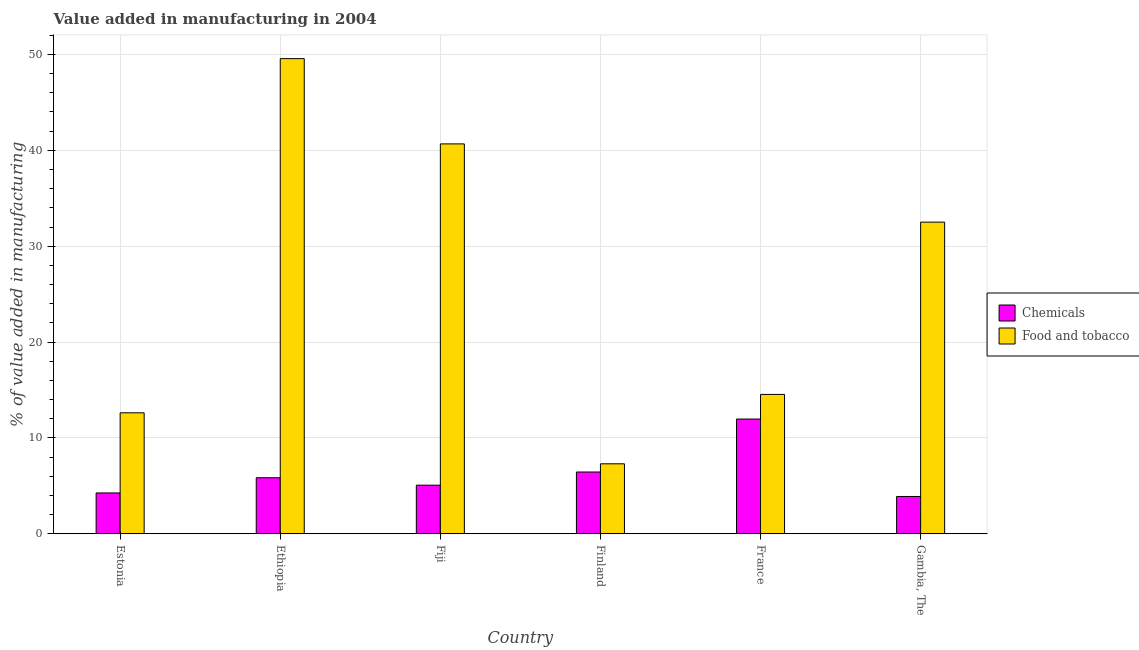How many different coloured bars are there?
Offer a terse response. 2. Are the number of bars per tick equal to the number of legend labels?
Give a very brief answer. Yes. How many bars are there on the 6th tick from the right?
Offer a terse response. 2. What is the label of the 4th group of bars from the left?
Your answer should be very brief. Finland. What is the value added by  manufacturing chemicals in Estonia?
Offer a very short reply. 4.27. Across all countries, what is the maximum value added by  manufacturing chemicals?
Ensure brevity in your answer.  11.97. Across all countries, what is the minimum value added by  manufacturing chemicals?
Provide a succinct answer. 3.9. In which country was the value added by manufacturing food and tobacco maximum?
Offer a terse response. Ethiopia. In which country was the value added by  manufacturing chemicals minimum?
Offer a terse response. Gambia, The. What is the total value added by  manufacturing chemicals in the graph?
Offer a terse response. 37.52. What is the difference between the value added by  manufacturing chemicals in Ethiopia and that in France?
Offer a terse response. -6.12. What is the difference between the value added by  manufacturing chemicals in Gambia, The and the value added by manufacturing food and tobacco in France?
Ensure brevity in your answer.  -10.64. What is the average value added by manufacturing food and tobacco per country?
Provide a succinct answer. 26.2. What is the difference between the value added by  manufacturing chemicals and value added by manufacturing food and tobacco in Finland?
Your answer should be compact. -0.86. In how many countries, is the value added by  manufacturing chemicals greater than 48 %?
Your response must be concise. 0. What is the ratio of the value added by manufacturing food and tobacco in Ethiopia to that in Finland?
Your answer should be very brief. 6.78. Is the value added by  manufacturing chemicals in Ethiopia less than that in France?
Offer a terse response. Yes. Is the difference between the value added by manufacturing food and tobacco in Estonia and Finland greater than the difference between the value added by  manufacturing chemicals in Estonia and Finland?
Provide a short and direct response. Yes. What is the difference between the highest and the second highest value added by  manufacturing chemicals?
Provide a short and direct response. 5.52. What is the difference between the highest and the lowest value added by  manufacturing chemicals?
Your response must be concise. 8.08. What does the 1st bar from the left in Finland represents?
Make the answer very short. Chemicals. What does the 1st bar from the right in Fiji represents?
Offer a terse response. Food and tobacco. How many countries are there in the graph?
Your response must be concise. 6. What is the difference between two consecutive major ticks on the Y-axis?
Keep it short and to the point. 10. Are the values on the major ticks of Y-axis written in scientific E-notation?
Make the answer very short. No. Does the graph contain any zero values?
Offer a very short reply. No. Does the graph contain grids?
Give a very brief answer. Yes. Where does the legend appear in the graph?
Give a very brief answer. Center right. How many legend labels are there?
Your answer should be compact. 2. How are the legend labels stacked?
Provide a succinct answer. Vertical. What is the title of the graph?
Keep it short and to the point. Value added in manufacturing in 2004. What is the label or title of the X-axis?
Give a very brief answer. Country. What is the label or title of the Y-axis?
Your response must be concise. % of value added in manufacturing. What is the % of value added in manufacturing of Chemicals in Estonia?
Your answer should be very brief. 4.27. What is the % of value added in manufacturing of Food and tobacco in Estonia?
Give a very brief answer. 12.63. What is the % of value added in manufacturing in Chemicals in Ethiopia?
Ensure brevity in your answer.  5.85. What is the % of value added in manufacturing in Food and tobacco in Ethiopia?
Give a very brief answer. 49.56. What is the % of value added in manufacturing of Chemicals in Fiji?
Offer a very short reply. 5.08. What is the % of value added in manufacturing in Food and tobacco in Fiji?
Provide a succinct answer. 40.67. What is the % of value added in manufacturing in Chemicals in Finland?
Your response must be concise. 6.45. What is the % of value added in manufacturing in Food and tobacco in Finland?
Provide a short and direct response. 7.31. What is the % of value added in manufacturing in Chemicals in France?
Make the answer very short. 11.97. What is the % of value added in manufacturing of Food and tobacco in France?
Provide a succinct answer. 14.54. What is the % of value added in manufacturing of Chemicals in Gambia, The?
Your answer should be very brief. 3.9. What is the % of value added in manufacturing in Food and tobacco in Gambia, The?
Provide a succinct answer. 32.51. Across all countries, what is the maximum % of value added in manufacturing in Chemicals?
Offer a terse response. 11.97. Across all countries, what is the maximum % of value added in manufacturing of Food and tobacco?
Offer a very short reply. 49.56. Across all countries, what is the minimum % of value added in manufacturing of Chemicals?
Offer a very short reply. 3.9. Across all countries, what is the minimum % of value added in manufacturing in Food and tobacco?
Offer a terse response. 7.31. What is the total % of value added in manufacturing in Chemicals in the graph?
Your response must be concise. 37.52. What is the total % of value added in manufacturing in Food and tobacco in the graph?
Your answer should be very brief. 157.21. What is the difference between the % of value added in manufacturing of Chemicals in Estonia and that in Ethiopia?
Your answer should be very brief. -1.59. What is the difference between the % of value added in manufacturing in Food and tobacco in Estonia and that in Ethiopia?
Give a very brief answer. -36.93. What is the difference between the % of value added in manufacturing of Chemicals in Estonia and that in Fiji?
Your answer should be very brief. -0.81. What is the difference between the % of value added in manufacturing in Food and tobacco in Estonia and that in Fiji?
Provide a short and direct response. -28.04. What is the difference between the % of value added in manufacturing in Chemicals in Estonia and that in Finland?
Offer a very short reply. -2.18. What is the difference between the % of value added in manufacturing of Food and tobacco in Estonia and that in Finland?
Provide a succinct answer. 5.32. What is the difference between the % of value added in manufacturing of Chemicals in Estonia and that in France?
Keep it short and to the point. -7.71. What is the difference between the % of value added in manufacturing in Food and tobacco in Estonia and that in France?
Your answer should be very brief. -1.92. What is the difference between the % of value added in manufacturing in Chemicals in Estonia and that in Gambia, The?
Your answer should be compact. 0.37. What is the difference between the % of value added in manufacturing of Food and tobacco in Estonia and that in Gambia, The?
Provide a short and direct response. -19.88. What is the difference between the % of value added in manufacturing in Chemicals in Ethiopia and that in Fiji?
Ensure brevity in your answer.  0.78. What is the difference between the % of value added in manufacturing in Food and tobacco in Ethiopia and that in Fiji?
Keep it short and to the point. 8.89. What is the difference between the % of value added in manufacturing of Chemicals in Ethiopia and that in Finland?
Provide a short and direct response. -0.6. What is the difference between the % of value added in manufacturing in Food and tobacco in Ethiopia and that in Finland?
Keep it short and to the point. 42.25. What is the difference between the % of value added in manufacturing of Chemicals in Ethiopia and that in France?
Offer a terse response. -6.12. What is the difference between the % of value added in manufacturing in Food and tobacco in Ethiopia and that in France?
Your answer should be very brief. 35.02. What is the difference between the % of value added in manufacturing of Chemicals in Ethiopia and that in Gambia, The?
Your response must be concise. 1.95. What is the difference between the % of value added in manufacturing of Food and tobacco in Ethiopia and that in Gambia, The?
Your response must be concise. 17.05. What is the difference between the % of value added in manufacturing of Chemicals in Fiji and that in Finland?
Offer a terse response. -1.37. What is the difference between the % of value added in manufacturing in Food and tobacco in Fiji and that in Finland?
Your answer should be very brief. 33.36. What is the difference between the % of value added in manufacturing of Chemicals in Fiji and that in France?
Your response must be concise. -6.9. What is the difference between the % of value added in manufacturing of Food and tobacco in Fiji and that in France?
Offer a very short reply. 26.13. What is the difference between the % of value added in manufacturing in Chemicals in Fiji and that in Gambia, The?
Provide a succinct answer. 1.18. What is the difference between the % of value added in manufacturing in Food and tobacco in Fiji and that in Gambia, The?
Keep it short and to the point. 8.16. What is the difference between the % of value added in manufacturing in Chemicals in Finland and that in France?
Keep it short and to the point. -5.52. What is the difference between the % of value added in manufacturing of Food and tobacco in Finland and that in France?
Keep it short and to the point. -7.24. What is the difference between the % of value added in manufacturing of Chemicals in Finland and that in Gambia, The?
Keep it short and to the point. 2.55. What is the difference between the % of value added in manufacturing in Food and tobacco in Finland and that in Gambia, The?
Keep it short and to the point. -25.2. What is the difference between the % of value added in manufacturing of Chemicals in France and that in Gambia, The?
Provide a succinct answer. 8.08. What is the difference between the % of value added in manufacturing of Food and tobacco in France and that in Gambia, The?
Your answer should be compact. -17.97. What is the difference between the % of value added in manufacturing of Chemicals in Estonia and the % of value added in manufacturing of Food and tobacco in Ethiopia?
Your answer should be very brief. -45.29. What is the difference between the % of value added in manufacturing of Chemicals in Estonia and the % of value added in manufacturing of Food and tobacco in Fiji?
Offer a very short reply. -36.4. What is the difference between the % of value added in manufacturing in Chemicals in Estonia and the % of value added in manufacturing in Food and tobacco in Finland?
Keep it short and to the point. -3.04. What is the difference between the % of value added in manufacturing of Chemicals in Estonia and the % of value added in manufacturing of Food and tobacco in France?
Keep it short and to the point. -10.28. What is the difference between the % of value added in manufacturing in Chemicals in Estonia and the % of value added in manufacturing in Food and tobacco in Gambia, The?
Offer a very short reply. -28.24. What is the difference between the % of value added in manufacturing in Chemicals in Ethiopia and the % of value added in manufacturing in Food and tobacco in Fiji?
Ensure brevity in your answer.  -34.81. What is the difference between the % of value added in manufacturing in Chemicals in Ethiopia and the % of value added in manufacturing in Food and tobacco in Finland?
Your answer should be very brief. -1.45. What is the difference between the % of value added in manufacturing of Chemicals in Ethiopia and the % of value added in manufacturing of Food and tobacco in France?
Your answer should be very brief. -8.69. What is the difference between the % of value added in manufacturing of Chemicals in Ethiopia and the % of value added in manufacturing of Food and tobacco in Gambia, The?
Keep it short and to the point. -26.66. What is the difference between the % of value added in manufacturing in Chemicals in Fiji and the % of value added in manufacturing in Food and tobacco in Finland?
Make the answer very short. -2.23. What is the difference between the % of value added in manufacturing of Chemicals in Fiji and the % of value added in manufacturing of Food and tobacco in France?
Offer a terse response. -9.47. What is the difference between the % of value added in manufacturing in Chemicals in Fiji and the % of value added in manufacturing in Food and tobacco in Gambia, The?
Make the answer very short. -27.43. What is the difference between the % of value added in manufacturing of Chemicals in Finland and the % of value added in manufacturing of Food and tobacco in France?
Offer a very short reply. -8.09. What is the difference between the % of value added in manufacturing in Chemicals in Finland and the % of value added in manufacturing in Food and tobacco in Gambia, The?
Your answer should be compact. -26.06. What is the difference between the % of value added in manufacturing of Chemicals in France and the % of value added in manufacturing of Food and tobacco in Gambia, The?
Your answer should be very brief. -20.53. What is the average % of value added in manufacturing of Chemicals per country?
Your answer should be very brief. 6.25. What is the average % of value added in manufacturing of Food and tobacco per country?
Give a very brief answer. 26.2. What is the difference between the % of value added in manufacturing in Chemicals and % of value added in manufacturing in Food and tobacco in Estonia?
Provide a short and direct response. -8.36. What is the difference between the % of value added in manufacturing in Chemicals and % of value added in manufacturing in Food and tobacco in Ethiopia?
Ensure brevity in your answer.  -43.71. What is the difference between the % of value added in manufacturing of Chemicals and % of value added in manufacturing of Food and tobacco in Fiji?
Offer a very short reply. -35.59. What is the difference between the % of value added in manufacturing in Chemicals and % of value added in manufacturing in Food and tobacco in Finland?
Make the answer very short. -0.86. What is the difference between the % of value added in manufacturing in Chemicals and % of value added in manufacturing in Food and tobacco in France?
Give a very brief answer. -2.57. What is the difference between the % of value added in manufacturing of Chemicals and % of value added in manufacturing of Food and tobacco in Gambia, The?
Offer a very short reply. -28.61. What is the ratio of the % of value added in manufacturing of Chemicals in Estonia to that in Ethiopia?
Offer a terse response. 0.73. What is the ratio of the % of value added in manufacturing in Food and tobacco in Estonia to that in Ethiopia?
Your response must be concise. 0.25. What is the ratio of the % of value added in manufacturing in Chemicals in Estonia to that in Fiji?
Provide a succinct answer. 0.84. What is the ratio of the % of value added in manufacturing in Food and tobacco in Estonia to that in Fiji?
Keep it short and to the point. 0.31. What is the ratio of the % of value added in manufacturing of Chemicals in Estonia to that in Finland?
Offer a very short reply. 0.66. What is the ratio of the % of value added in manufacturing of Food and tobacco in Estonia to that in Finland?
Provide a succinct answer. 1.73. What is the ratio of the % of value added in manufacturing in Chemicals in Estonia to that in France?
Give a very brief answer. 0.36. What is the ratio of the % of value added in manufacturing in Food and tobacco in Estonia to that in France?
Provide a succinct answer. 0.87. What is the ratio of the % of value added in manufacturing in Chemicals in Estonia to that in Gambia, The?
Provide a short and direct response. 1.09. What is the ratio of the % of value added in manufacturing of Food and tobacco in Estonia to that in Gambia, The?
Offer a terse response. 0.39. What is the ratio of the % of value added in manufacturing in Chemicals in Ethiopia to that in Fiji?
Ensure brevity in your answer.  1.15. What is the ratio of the % of value added in manufacturing in Food and tobacco in Ethiopia to that in Fiji?
Offer a very short reply. 1.22. What is the ratio of the % of value added in manufacturing in Chemicals in Ethiopia to that in Finland?
Offer a terse response. 0.91. What is the ratio of the % of value added in manufacturing of Food and tobacco in Ethiopia to that in Finland?
Your answer should be compact. 6.78. What is the ratio of the % of value added in manufacturing in Chemicals in Ethiopia to that in France?
Your answer should be very brief. 0.49. What is the ratio of the % of value added in manufacturing of Food and tobacco in Ethiopia to that in France?
Provide a short and direct response. 3.41. What is the ratio of the % of value added in manufacturing of Chemicals in Ethiopia to that in Gambia, The?
Make the answer very short. 1.5. What is the ratio of the % of value added in manufacturing of Food and tobacco in Ethiopia to that in Gambia, The?
Make the answer very short. 1.52. What is the ratio of the % of value added in manufacturing in Chemicals in Fiji to that in Finland?
Your answer should be very brief. 0.79. What is the ratio of the % of value added in manufacturing in Food and tobacco in Fiji to that in Finland?
Give a very brief answer. 5.57. What is the ratio of the % of value added in manufacturing in Chemicals in Fiji to that in France?
Ensure brevity in your answer.  0.42. What is the ratio of the % of value added in manufacturing of Food and tobacco in Fiji to that in France?
Your response must be concise. 2.8. What is the ratio of the % of value added in manufacturing of Chemicals in Fiji to that in Gambia, The?
Keep it short and to the point. 1.3. What is the ratio of the % of value added in manufacturing of Food and tobacco in Fiji to that in Gambia, The?
Your answer should be compact. 1.25. What is the ratio of the % of value added in manufacturing in Chemicals in Finland to that in France?
Give a very brief answer. 0.54. What is the ratio of the % of value added in manufacturing in Food and tobacco in Finland to that in France?
Your answer should be compact. 0.5. What is the ratio of the % of value added in manufacturing in Chemicals in Finland to that in Gambia, The?
Your answer should be very brief. 1.65. What is the ratio of the % of value added in manufacturing of Food and tobacco in Finland to that in Gambia, The?
Make the answer very short. 0.22. What is the ratio of the % of value added in manufacturing in Chemicals in France to that in Gambia, The?
Your answer should be very brief. 3.07. What is the ratio of the % of value added in manufacturing in Food and tobacco in France to that in Gambia, The?
Give a very brief answer. 0.45. What is the difference between the highest and the second highest % of value added in manufacturing of Chemicals?
Give a very brief answer. 5.52. What is the difference between the highest and the second highest % of value added in manufacturing in Food and tobacco?
Offer a very short reply. 8.89. What is the difference between the highest and the lowest % of value added in manufacturing of Chemicals?
Your response must be concise. 8.08. What is the difference between the highest and the lowest % of value added in manufacturing in Food and tobacco?
Offer a very short reply. 42.25. 